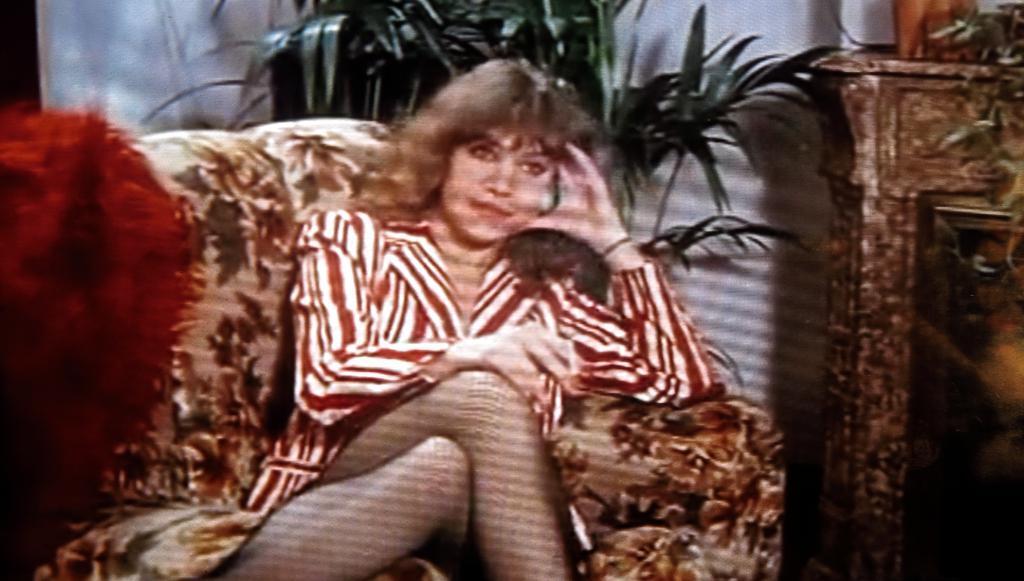Describe this image in one or two sentences. In this image we can see a woman sitting on the couch, there is a table beside the couch and a red color object on the left side, in the background there is a house plant and a wall. 